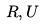<formula> <loc_0><loc_0><loc_500><loc_500>R , U</formula> 